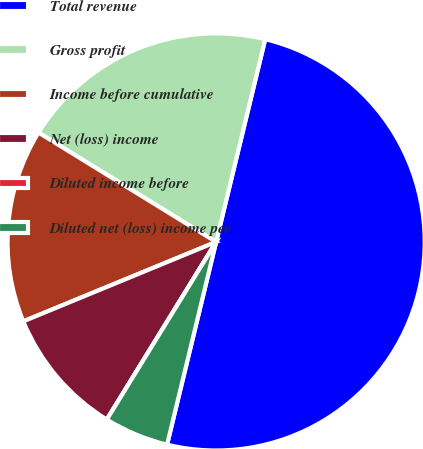Convert chart to OTSL. <chart><loc_0><loc_0><loc_500><loc_500><pie_chart><fcel>Total revenue<fcel>Gross profit<fcel>Income before cumulative<fcel>Net (loss) income<fcel>Diluted income before<fcel>Diluted net (loss) income per<nl><fcel>50.0%<fcel>20.0%<fcel>15.0%<fcel>10.0%<fcel>0.0%<fcel>5.0%<nl></chart> 